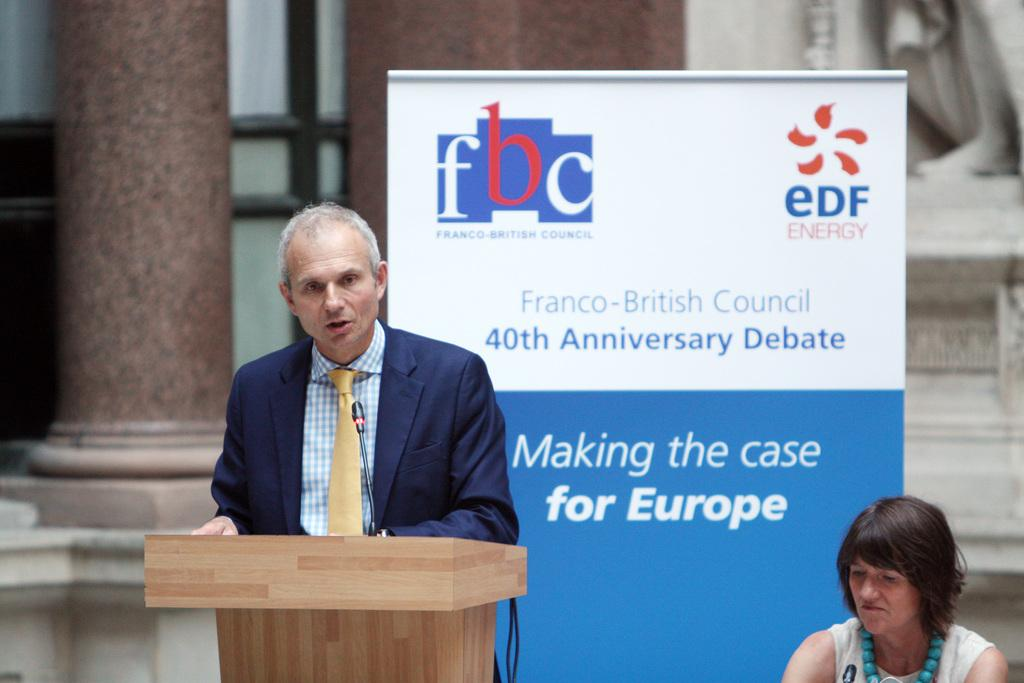What is the main subject in the center of the image? There is a person standing at a desk in the center of the image. What is the woman doing on the right side of the image? The woman is sitting on the right side of the image. What can be seen in the background of the image? There is a poster, a pillar, and a wall in the background of the image. What language is the sand speaking in the image? There is no sand present in the image, and therefore it cannot speak any language. Is the lawyer present in the image? There is no mention of a lawyer in the provided facts, so we cannot determine if one is present in the image. 